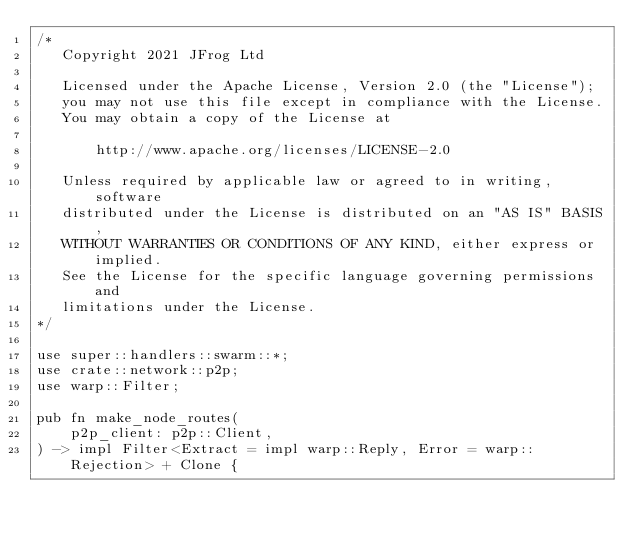<code> <loc_0><loc_0><loc_500><loc_500><_Rust_>/*
   Copyright 2021 JFrog Ltd

   Licensed under the Apache License, Version 2.0 (the "License");
   you may not use this file except in compliance with the License.
   You may obtain a copy of the License at

       http://www.apache.org/licenses/LICENSE-2.0

   Unless required by applicable law or agreed to in writing, software
   distributed under the License is distributed on an "AS IS" BASIS,
   WITHOUT WARRANTIES OR CONDITIONS OF ANY KIND, either express or implied.
   See the License for the specific language governing permissions and
   limitations under the License.
*/

use super::handlers::swarm::*;
use crate::network::p2p;
use warp::Filter;

pub fn make_node_routes(
    p2p_client: p2p::Client,
) -> impl Filter<Extract = impl warp::Reply, Error = warp::Rejection> + Clone {</code> 